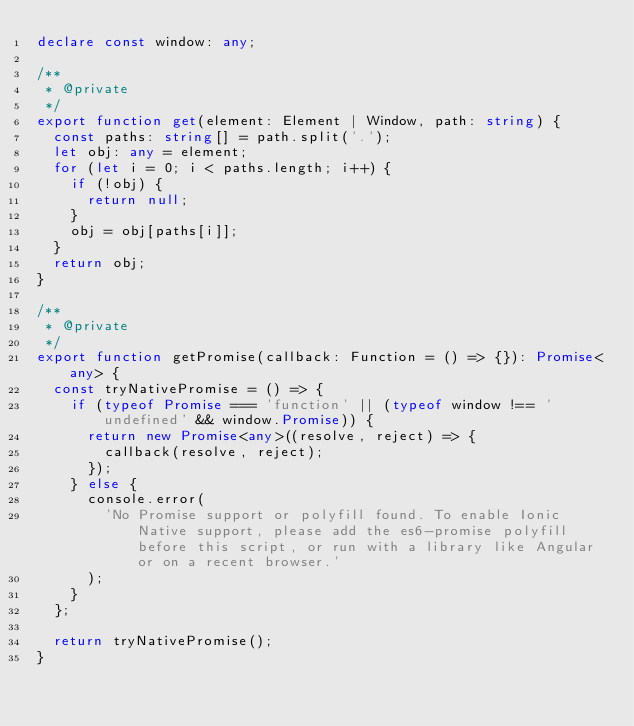<code> <loc_0><loc_0><loc_500><loc_500><_TypeScript_>declare const window: any;

/**
 * @private
 */
export function get(element: Element | Window, path: string) {
  const paths: string[] = path.split('.');
  let obj: any = element;
  for (let i = 0; i < paths.length; i++) {
    if (!obj) {
      return null;
    }
    obj = obj[paths[i]];
  }
  return obj;
}

/**
 * @private
 */
export function getPromise(callback: Function = () => {}): Promise<any> {
  const tryNativePromise = () => {
    if (typeof Promise === 'function' || (typeof window !== 'undefined' && window.Promise)) {
      return new Promise<any>((resolve, reject) => {
        callback(resolve, reject);
      });
    } else {
      console.error(
        'No Promise support or polyfill found. To enable Ionic Native support, please add the es6-promise polyfill before this script, or run with a library like Angular or on a recent browser.'
      );
    }
  };

  return tryNativePromise();
}
</code> 